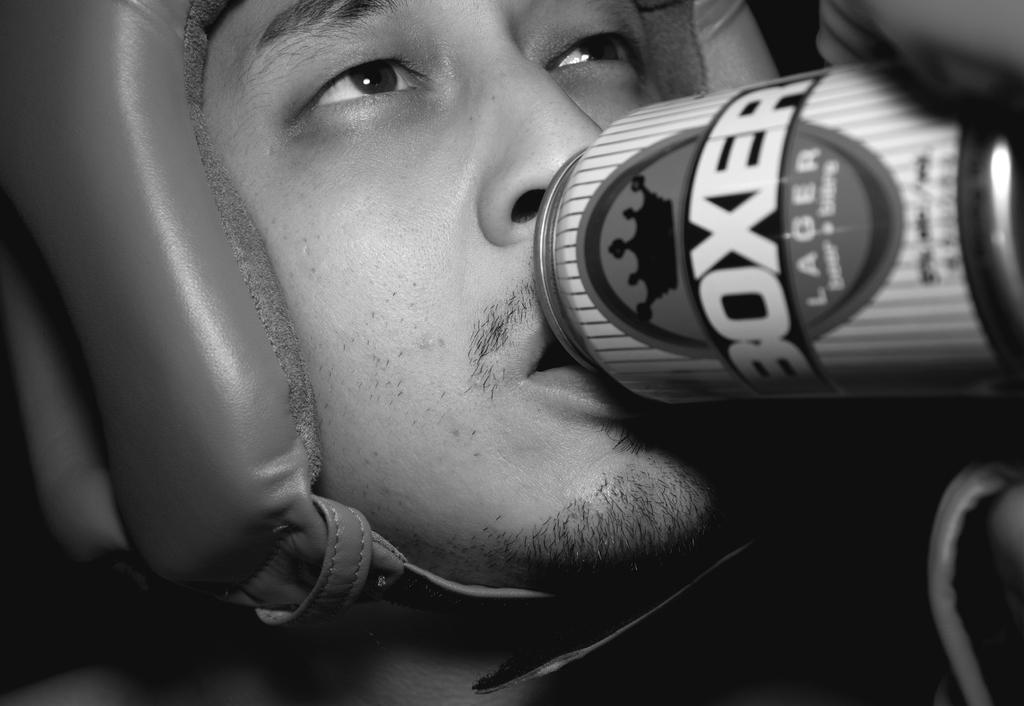<image>
Write a terse but informative summary of the picture. A man drinking a can of BOXER LAGER. 